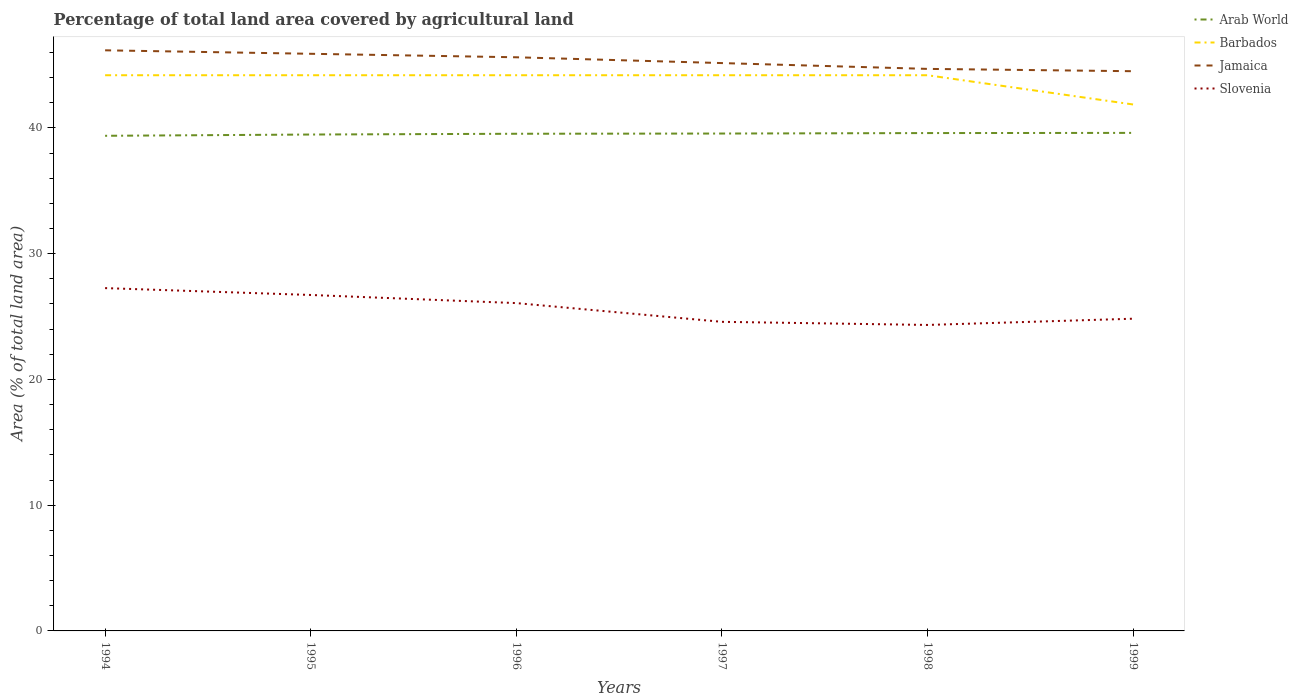Does the line corresponding to Arab World intersect with the line corresponding to Barbados?
Ensure brevity in your answer.  No. Across all years, what is the maximum percentage of agricultural land in Barbados?
Ensure brevity in your answer.  41.86. In which year was the percentage of agricultural land in Slovenia maximum?
Provide a succinct answer. 1998. What is the total percentage of agricultural land in Arab World in the graph?
Make the answer very short. -0.05. What is the difference between the highest and the second highest percentage of agricultural land in Slovenia?
Offer a very short reply. 2.93. What is the difference between the highest and the lowest percentage of agricultural land in Jamaica?
Your response must be concise. 3. How many lines are there?
Give a very brief answer. 4. How many years are there in the graph?
Give a very brief answer. 6. Does the graph contain any zero values?
Provide a short and direct response. No. Does the graph contain grids?
Make the answer very short. No. How many legend labels are there?
Make the answer very short. 4. What is the title of the graph?
Offer a terse response. Percentage of total land area covered by agricultural land. Does "Georgia" appear as one of the legend labels in the graph?
Ensure brevity in your answer.  No. What is the label or title of the X-axis?
Give a very brief answer. Years. What is the label or title of the Y-axis?
Offer a very short reply. Area (% of total land area). What is the Area (% of total land area) in Arab World in 1994?
Provide a short and direct response. 39.37. What is the Area (% of total land area) in Barbados in 1994?
Your response must be concise. 44.19. What is the Area (% of total land area) in Jamaica in 1994?
Give a very brief answer. 46.17. What is the Area (% of total land area) in Slovenia in 1994?
Give a very brief answer. 27.26. What is the Area (% of total land area) in Arab World in 1995?
Make the answer very short. 39.47. What is the Area (% of total land area) of Barbados in 1995?
Provide a succinct answer. 44.19. What is the Area (% of total land area) of Jamaica in 1995?
Provide a short and direct response. 45.89. What is the Area (% of total land area) of Slovenia in 1995?
Ensure brevity in your answer.  26.71. What is the Area (% of total land area) of Arab World in 1996?
Provide a short and direct response. 39.53. What is the Area (% of total land area) in Barbados in 1996?
Provide a short and direct response. 44.19. What is the Area (% of total land area) in Jamaica in 1996?
Your response must be concise. 45.61. What is the Area (% of total land area) in Slovenia in 1996?
Provide a succinct answer. 26.07. What is the Area (% of total land area) in Arab World in 1997?
Provide a succinct answer. 39.55. What is the Area (% of total land area) in Barbados in 1997?
Keep it short and to the point. 44.19. What is the Area (% of total land area) of Jamaica in 1997?
Provide a short and direct response. 45.15. What is the Area (% of total land area) in Slovenia in 1997?
Offer a very short reply. 24.58. What is the Area (% of total land area) of Arab World in 1998?
Provide a succinct answer. 39.59. What is the Area (% of total land area) in Barbados in 1998?
Make the answer very short. 44.19. What is the Area (% of total land area) of Jamaica in 1998?
Provide a short and direct response. 44.69. What is the Area (% of total land area) in Slovenia in 1998?
Keep it short and to the point. 24.33. What is the Area (% of total land area) of Arab World in 1999?
Make the answer very short. 39.6. What is the Area (% of total land area) of Barbados in 1999?
Offer a terse response. 41.86. What is the Area (% of total land area) in Jamaica in 1999?
Offer a terse response. 44.51. What is the Area (% of total land area) of Slovenia in 1999?
Offer a very short reply. 24.83. Across all years, what is the maximum Area (% of total land area) of Arab World?
Provide a succinct answer. 39.6. Across all years, what is the maximum Area (% of total land area) of Barbados?
Provide a short and direct response. 44.19. Across all years, what is the maximum Area (% of total land area) of Jamaica?
Provide a short and direct response. 46.17. Across all years, what is the maximum Area (% of total land area) of Slovenia?
Make the answer very short. 27.26. Across all years, what is the minimum Area (% of total land area) of Arab World?
Your answer should be compact. 39.37. Across all years, what is the minimum Area (% of total land area) in Barbados?
Give a very brief answer. 41.86. Across all years, what is the minimum Area (% of total land area) in Jamaica?
Offer a very short reply. 44.51. Across all years, what is the minimum Area (% of total land area) in Slovenia?
Keep it short and to the point. 24.33. What is the total Area (% of total land area) in Arab World in the graph?
Give a very brief answer. 237.11. What is the total Area (% of total land area) of Barbados in the graph?
Give a very brief answer. 262.79. What is the total Area (% of total land area) in Jamaica in the graph?
Your answer should be compact. 272.02. What is the total Area (% of total land area) of Slovenia in the graph?
Keep it short and to the point. 153.77. What is the difference between the Area (% of total land area) in Arab World in 1994 and that in 1995?
Your answer should be very brief. -0.1. What is the difference between the Area (% of total land area) of Jamaica in 1994 and that in 1995?
Offer a terse response. 0.28. What is the difference between the Area (% of total land area) in Slovenia in 1994 and that in 1995?
Offer a terse response. 0.55. What is the difference between the Area (% of total land area) of Arab World in 1994 and that in 1996?
Provide a succinct answer. -0.16. What is the difference between the Area (% of total land area) of Barbados in 1994 and that in 1996?
Give a very brief answer. 0. What is the difference between the Area (% of total land area) in Jamaica in 1994 and that in 1996?
Keep it short and to the point. 0.55. What is the difference between the Area (% of total land area) of Slovenia in 1994 and that in 1996?
Give a very brief answer. 1.19. What is the difference between the Area (% of total land area) of Arab World in 1994 and that in 1997?
Ensure brevity in your answer.  -0.18. What is the difference between the Area (% of total land area) of Barbados in 1994 and that in 1997?
Offer a very short reply. 0. What is the difference between the Area (% of total land area) in Jamaica in 1994 and that in 1997?
Give a very brief answer. 1.02. What is the difference between the Area (% of total land area) in Slovenia in 1994 and that in 1997?
Provide a succinct answer. 2.68. What is the difference between the Area (% of total land area) of Arab World in 1994 and that in 1998?
Make the answer very short. -0.22. What is the difference between the Area (% of total land area) of Jamaica in 1994 and that in 1998?
Ensure brevity in your answer.  1.48. What is the difference between the Area (% of total land area) of Slovenia in 1994 and that in 1998?
Your answer should be very brief. 2.93. What is the difference between the Area (% of total land area) of Arab World in 1994 and that in 1999?
Make the answer very short. -0.23. What is the difference between the Area (% of total land area) of Barbados in 1994 and that in 1999?
Give a very brief answer. 2.33. What is the difference between the Area (% of total land area) in Jamaica in 1994 and that in 1999?
Keep it short and to the point. 1.66. What is the difference between the Area (% of total land area) of Slovenia in 1994 and that in 1999?
Give a very brief answer. 2.43. What is the difference between the Area (% of total land area) of Arab World in 1995 and that in 1996?
Keep it short and to the point. -0.06. What is the difference between the Area (% of total land area) of Jamaica in 1995 and that in 1996?
Your response must be concise. 0.28. What is the difference between the Area (% of total land area) in Slovenia in 1995 and that in 1996?
Make the answer very short. 0.65. What is the difference between the Area (% of total land area) in Arab World in 1995 and that in 1997?
Your response must be concise. -0.08. What is the difference between the Area (% of total land area) in Barbados in 1995 and that in 1997?
Offer a terse response. 0. What is the difference between the Area (% of total land area) of Jamaica in 1995 and that in 1997?
Your answer should be very brief. 0.74. What is the difference between the Area (% of total land area) in Slovenia in 1995 and that in 1997?
Your answer should be very brief. 2.14. What is the difference between the Area (% of total land area) of Arab World in 1995 and that in 1998?
Give a very brief answer. -0.12. What is the difference between the Area (% of total land area) of Jamaica in 1995 and that in 1998?
Your response must be concise. 1.2. What is the difference between the Area (% of total land area) of Slovenia in 1995 and that in 1998?
Your answer should be compact. 2.38. What is the difference between the Area (% of total land area) in Arab World in 1995 and that in 1999?
Your answer should be compact. -0.13. What is the difference between the Area (% of total land area) of Barbados in 1995 and that in 1999?
Keep it short and to the point. 2.33. What is the difference between the Area (% of total land area) of Jamaica in 1995 and that in 1999?
Provide a succinct answer. 1.39. What is the difference between the Area (% of total land area) of Slovenia in 1995 and that in 1999?
Offer a very short reply. 1.89. What is the difference between the Area (% of total land area) in Arab World in 1996 and that in 1997?
Provide a short and direct response. -0.02. What is the difference between the Area (% of total land area) of Barbados in 1996 and that in 1997?
Offer a very short reply. 0. What is the difference between the Area (% of total land area) of Jamaica in 1996 and that in 1997?
Keep it short and to the point. 0.46. What is the difference between the Area (% of total land area) in Slovenia in 1996 and that in 1997?
Your response must be concise. 1.49. What is the difference between the Area (% of total land area) of Arab World in 1996 and that in 1998?
Provide a succinct answer. -0.05. What is the difference between the Area (% of total land area) of Barbados in 1996 and that in 1998?
Your answer should be very brief. 0. What is the difference between the Area (% of total land area) of Jamaica in 1996 and that in 1998?
Provide a short and direct response. 0.92. What is the difference between the Area (% of total land area) in Slovenia in 1996 and that in 1998?
Make the answer very short. 1.74. What is the difference between the Area (% of total land area) of Arab World in 1996 and that in 1999?
Offer a terse response. -0.07. What is the difference between the Area (% of total land area) in Barbados in 1996 and that in 1999?
Your answer should be compact. 2.33. What is the difference between the Area (% of total land area) in Jamaica in 1996 and that in 1999?
Make the answer very short. 1.11. What is the difference between the Area (% of total land area) in Slovenia in 1996 and that in 1999?
Keep it short and to the point. 1.24. What is the difference between the Area (% of total land area) in Arab World in 1997 and that in 1998?
Give a very brief answer. -0.04. What is the difference between the Area (% of total land area) in Jamaica in 1997 and that in 1998?
Your answer should be compact. 0.46. What is the difference between the Area (% of total land area) of Slovenia in 1997 and that in 1998?
Your answer should be very brief. 0.25. What is the difference between the Area (% of total land area) in Arab World in 1997 and that in 1999?
Your answer should be compact. -0.05. What is the difference between the Area (% of total land area) of Barbados in 1997 and that in 1999?
Your answer should be compact. 2.33. What is the difference between the Area (% of total land area) in Jamaica in 1997 and that in 1999?
Offer a very short reply. 0.65. What is the difference between the Area (% of total land area) in Slovenia in 1997 and that in 1999?
Make the answer very short. -0.25. What is the difference between the Area (% of total land area) in Arab World in 1998 and that in 1999?
Ensure brevity in your answer.  -0.01. What is the difference between the Area (% of total land area) in Barbados in 1998 and that in 1999?
Ensure brevity in your answer.  2.33. What is the difference between the Area (% of total land area) in Jamaica in 1998 and that in 1999?
Provide a short and direct response. 0.18. What is the difference between the Area (% of total land area) of Slovenia in 1998 and that in 1999?
Keep it short and to the point. -0.5. What is the difference between the Area (% of total land area) of Arab World in 1994 and the Area (% of total land area) of Barbados in 1995?
Offer a terse response. -4.82. What is the difference between the Area (% of total land area) of Arab World in 1994 and the Area (% of total land area) of Jamaica in 1995?
Your answer should be very brief. -6.52. What is the difference between the Area (% of total land area) in Arab World in 1994 and the Area (% of total land area) in Slovenia in 1995?
Provide a succinct answer. 12.66. What is the difference between the Area (% of total land area) in Barbados in 1994 and the Area (% of total land area) in Jamaica in 1995?
Provide a short and direct response. -1.71. What is the difference between the Area (% of total land area) in Barbados in 1994 and the Area (% of total land area) in Slovenia in 1995?
Offer a terse response. 17.47. What is the difference between the Area (% of total land area) of Jamaica in 1994 and the Area (% of total land area) of Slovenia in 1995?
Your answer should be very brief. 19.45. What is the difference between the Area (% of total land area) of Arab World in 1994 and the Area (% of total land area) of Barbados in 1996?
Your answer should be very brief. -4.82. What is the difference between the Area (% of total land area) of Arab World in 1994 and the Area (% of total land area) of Jamaica in 1996?
Offer a terse response. -6.24. What is the difference between the Area (% of total land area) in Arab World in 1994 and the Area (% of total land area) in Slovenia in 1996?
Keep it short and to the point. 13.3. What is the difference between the Area (% of total land area) in Barbados in 1994 and the Area (% of total land area) in Jamaica in 1996?
Your answer should be compact. -1.43. What is the difference between the Area (% of total land area) of Barbados in 1994 and the Area (% of total land area) of Slovenia in 1996?
Make the answer very short. 18.12. What is the difference between the Area (% of total land area) in Jamaica in 1994 and the Area (% of total land area) in Slovenia in 1996?
Your response must be concise. 20.1. What is the difference between the Area (% of total land area) in Arab World in 1994 and the Area (% of total land area) in Barbados in 1997?
Provide a succinct answer. -4.82. What is the difference between the Area (% of total land area) in Arab World in 1994 and the Area (% of total land area) in Jamaica in 1997?
Offer a terse response. -5.78. What is the difference between the Area (% of total land area) in Arab World in 1994 and the Area (% of total land area) in Slovenia in 1997?
Provide a succinct answer. 14.79. What is the difference between the Area (% of total land area) of Barbados in 1994 and the Area (% of total land area) of Jamaica in 1997?
Keep it short and to the point. -0.97. What is the difference between the Area (% of total land area) of Barbados in 1994 and the Area (% of total land area) of Slovenia in 1997?
Offer a terse response. 19.61. What is the difference between the Area (% of total land area) of Jamaica in 1994 and the Area (% of total land area) of Slovenia in 1997?
Your answer should be compact. 21.59. What is the difference between the Area (% of total land area) of Arab World in 1994 and the Area (% of total land area) of Barbados in 1998?
Your response must be concise. -4.82. What is the difference between the Area (% of total land area) of Arab World in 1994 and the Area (% of total land area) of Jamaica in 1998?
Give a very brief answer. -5.32. What is the difference between the Area (% of total land area) of Arab World in 1994 and the Area (% of total land area) of Slovenia in 1998?
Provide a succinct answer. 15.04. What is the difference between the Area (% of total land area) of Barbados in 1994 and the Area (% of total land area) of Jamaica in 1998?
Your answer should be compact. -0.5. What is the difference between the Area (% of total land area) of Barbados in 1994 and the Area (% of total land area) of Slovenia in 1998?
Your response must be concise. 19.86. What is the difference between the Area (% of total land area) of Jamaica in 1994 and the Area (% of total land area) of Slovenia in 1998?
Keep it short and to the point. 21.84. What is the difference between the Area (% of total land area) of Arab World in 1994 and the Area (% of total land area) of Barbados in 1999?
Keep it short and to the point. -2.49. What is the difference between the Area (% of total land area) of Arab World in 1994 and the Area (% of total land area) of Jamaica in 1999?
Keep it short and to the point. -5.14. What is the difference between the Area (% of total land area) in Arab World in 1994 and the Area (% of total land area) in Slovenia in 1999?
Provide a succinct answer. 14.54. What is the difference between the Area (% of total land area) of Barbados in 1994 and the Area (% of total land area) of Jamaica in 1999?
Make the answer very short. -0.32. What is the difference between the Area (% of total land area) of Barbados in 1994 and the Area (% of total land area) of Slovenia in 1999?
Give a very brief answer. 19.36. What is the difference between the Area (% of total land area) of Jamaica in 1994 and the Area (% of total land area) of Slovenia in 1999?
Your answer should be compact. 21.34. What is the difference between the Area (% of total land area) of Arab World in 1995 and the Area (% of total land area) of Barbados in 1996?
Your answer should be compact. -4.71. What is the difference between the Area (% of total land area) in Arab World in 1995 and the Area (% of total land area) in Jamaica in 1996?
Keep it short and to the point. -6.14. What is the difference between the Area (% of total land area) of Arab World in 1995 and the Area (% of total land area) of Slovenia in 1996?
Offer a very short reply. 13.4. What is the difference between the Area (% of total land area) of Barbados in 1995 and the Area (% of total land area) of Jamaica in 1996?
Your answer should be compact. -1.43. What is the difference between the Area (% of total land area) of Barbados in 1995 and the Area (% of total land area) of Slovenia in 1996?
Provide a succinct answer. 18.12. What is the difference between the Area (% of total land area) of Jamaica in 1995 and the Area (% of total land area) of Slovenia in 1996?
Provide a short and direct response. 19.82. What is the difference between the Area (% of total land area) in Arab World in 1995 and the Area (% of total land area) in Barbados in 1997?
Offer a terse response. -4.71. What is the difference between the Area (% of total land area) in Arab World in 1995 and the Area (% of total land area) in Jamaica in 1997?
Give a very brief answer. -5.68. What is the difference between the Area (% of total land area) in Arab World in 1995 and the Area (% of total land area) in Slovenia in 1997?
Give a very brief answer. 14.89. What is the difference between the Area (% of total land area) of Barbados in 1995 and the Area (% of total land area) of Jamaica in 1997?
Give a very brief answer. -0.97. What is the difference between the Area (% of total land area) of Barbados in 1995 and the Area (% of total land area) of Slovenia in 1997?
Give a very brief answer. 19.61. What is the difference between the Area (% of total land area) of Jamaica in 1995 and the Area (% of total land area) of Slovenia in 1997?
Offer a very short reply. 21.31. What is the difference between the Area (% of total land area) in Arab World in 1995 and the Area (% of total land area) in Barbados in 1998?
Your answer should be very brief. -4.71. What is the difference between the Area (% of total land area) in Arab World in 1995 and the Area (% of total land area) in Jamaica in 1998?
Make the answer very short. -5.22. What is the difference between the Area (% of total land area) of Arab World in 1995 and the Area (% of total land area) of Slovenia in 1998?
Ensure brevity in your answer.  15.14. What is the difference between the Area (% of total land area) of Barbados in 1995 and the Area (% of total land area) of Jamaica in 1998?
Your answer should be compact. -0.5. What is the difference between the Area (% of total land area) of Barbados in 1995 and the Area (% of total land area) of Slovenia in 1998?
Ensure brevity in your answer.  19.86. What is the difference between the Area (% of total land area) of Jamaica in 1995 and the Area (% of total land area) of Slovenia in 1998?
Provide a succinct answer. 21.56. What is the difference between the Area (% of total land area) of Arab World in 1995 and the Area (% of total land area) of Barbados in 1999?
Provide a succinct answer. -2.39. What is the difference between the Area (% of total land area) of Arab World in 1995 and the Area (% of total land area) of Jamaica in 1999?
Ensure brevity in your answer.  -5.03. What is the difference between the Area (% of total land area) in Arab World in 1995 and the Area (% of total land area) in Slovenia in 1999?
Make the answer very short. 14.64. What is the difference between the Area (% of total land area) of Barbados in 1995 and the Area (% of total land area) of Jamaica in 1999?
Provide a succinct answer. -0.32. What is the difference between the Area (% of total land area) of Barbados in 1995 and the Area (% of total land area) of Slovenia in 1999?
Your answer should be compact. 19.36. What is the difference between the Area (% of total land area) in Jamaica in 1995 and the Area (% of total land area) in Slovenia in 1999?
Give a very brief answer. 21.06. What is the difference between the Area (% of total land area) in Arab World in 1996 and the Area (% of total land area) in Barbados in 1997?
Make the answer very short. -4.65. What is the difference between the Area (% of total land area) in Arab World in 1996 and the Area (% of total land area) in Jamaica in 1997?
Ensure brevity in your answer.  -5.62. What is the difference between the Area (% of total land area) in Arab World in 1996 and the Area (% of total land area) in Slovenia in 1997?
Offer a very short reply. 14.95. What is the difference between the Area (% of total land area) in Barbados in 1996 and the Area (% of total land area) in Jamaica in 1997?
Your response must be concise. -0.97. What is the difference between the Area (% of total land area) of Barbados in 1996 and the Area (% of total land area) of Slovenia in 1997?
Ensure brevity in your answer.  19.61. What is the difference between the Area (% of total land area) of Jamaica in 1996 and the Area (% of total land area) of Slovenia in 1997?
Offer a terse response. 21.04. What is the difference between the Area (% of total land area) of Arab World in 1996 and the Area (% of total land area) of Barbados in 1998?
Provide a succinct answer. -4.65. What is the difference between the Area (% of total land area) in Arab World in 1996 and the Area (% of total land area) in Jamaica in 1998?
Keep it short and to the point. -5.16. What is the difference between the Area (% of total land area) in Arab World in 1996 and the Area (% of total land area) in Slovenia in 1998?
Ensure brevity in your answer.  15.2. What is the difference between the Area (% of total land area) in Barbados in 1996 and the Area (% of total land area) in Jamaica in 1998?
Your answer should be compact. -0.5. What is the difference between the Area (% of total land area) in Barbados in 1996 and the Area (% of total land area) in Slovenia in 1998?
Provide a succinct answer. 19.86. What is the difference between the Area (% of total land area) in Jamaica in 1996 and the Area (% of total land area) in Slovenia in 1998?
Your answer should be compact. 21.28. What is the difference between the Area (% of total land area) in Arab World in 1996 and the Area (% of total land area) in Barbados in 1999?
Offer a very short reply. -2.33. What is the difference between the Area (% of total land area) of Arab World in 1996 and the Area (% of total land area) of Jamaica in 1999?
Offer a very short reply. -4.97. What is the difference between the Area (% of total land area) in Arab World in 1996 and the Area (% of total land area) in Slovenia in 1999?
Your response must be concise. 14.71. What is the difference between the Area (% of total land area) in Barbados in 1996 and the Area (% of total land area) in Jamaica in 1999?
Make the answer very short. -0.32. What is the difference between the Area (% of total land area) of Barbados in 1996 and the Area (% of total land area) of Slovenia in 1999?
Keep it short and to the point. 19.36. What is the difference between the Area (% of total land area) of Jamaica in 1996 and the Area (% of total land area) of Slovenia in 1999?
Provide a succinct answer. 20.79. What is the difference between the Area (% of total land area) of Arab World in 1997 and the Area (% of total land area) of Barbados in 1998?
Ensure brevity in your answer.  -4.64. What is the difference between the Area (% of total land area) in Arab World in 1997 and the Area (% of total land area) in Jamaica in 1998?
Make the answer very short. -5.14. What is the difference between the Area (% of total land area) in Arab World in 1997 and the Area (% of total land area) in Slovenia in 1998?
Give a very brief answer. 15.22. What is the difference between the Area (% of total land area) of Barbados in 1997 and the Area (% of total land area) of Jamaica in 1998?
Make the answer very short. -0.5. What is the difference between the Area (% of total land area) of Barbados in 1997 and the Area (% of total land area) of Slovenia in 1998?
Make the answer very short. 19.86. What is the difference between the Area (% of total land area) of Jamaica in 1997 and the Area (% of total land area) of Slovenia in 1998?
Make the answer very short. 20.82. What is the difference between the Area (% of total land area) of Arab World in 1997 and the Area (% of total land area) of Barbados in 1999?
Your answer should be very brief. -2.31. What is the difference between the Area (% of total land area) of Arab World in 1997 and the Area (% of total land area) of Jamaica in 1999?
Offer a terse response. -4.96. What is the difference between the Area (% of total land area) of Arab World in 1997 and the Area (% of total land area) of Slovenia in 1999?
Your answer should be compact. 14.72. What is the difference between the Area (% of total land area) in Barbados in 1997 and the Area (% of total land area) in Jamaica in 1999?
Your answer should be very brief. -0.32. What is the difference between the Area (% of total land area) in Barbados in 1997 and the Area (% of total land area) in Slovenia in 1999?
Your answer should be very brief. 19.36. What is the difference between the Area (% of total land area) of Jamaica in 1997 and the Area (% of total land area) of Slovenia in 1999?
Make the answer very short. 20.33. What is the difference between the Area (% of total land area) of Arab World in 1998 and the Area (% of total land area) of Barbados in 1999?
Offer a very short reply. -2.27. What is the difference between the Area (% of total land area) of Arab World in 1998 and the Area (% of total land area) of Jamaica in 1999?
Provide a short and direct response. -4.92. What is the difference between the Area (% of total land area) of Arab World in 1998 and the Area (% of total land area) of Slovenia in 1999?
Provide a short and direct response. 14.76. What is the difference between the Area (% of total land area) of Barbados in 1998 and the Area (% of total land area) of Jamaica in 1999?
Keep it short and to the point. -0.32. What is the difference between the Area (% of total land area) in Barbados in 1998 and the Area (% of total land area) in Slovenia in 1999?
Provide a short and direct response. 19.36. What is the difference between the Area (% of total land area) in Jamaica in 1998 and the Area (% of total land area) in Slovenia in 1999?
Give a very brief answer. 19.86. What is the average Area (% of total land area) of Arab World per year?
Offer a terse response. 39.52. What is the average Area (% of total land area) in Barbados per year?
Offer a very short reply. 43.8. What is the average Area (% of total land area) in Jamaica per year?
Give a very brief answer. 45.34. What is the average Area (% of total land area) in Slovenia per year?
Provide a succinct answer. 25.63. In the year 1994, what is the difference between the Area (% of total land area) of Arab World and Area (% of total land area) of Barbados?
Ensure brevity in your answer.  -4.82. In the year 1994, what is the difference between the Area (% of total land area) of Arab World and Area (% of total land area) of Jamaica?
Provide a succinct answer. -6.8. In the year 1994, what is the difference between the Area (% of total land area) of Arab World and Area (% of total land area) of Slovenia?
Provide a succinct answer. 12.11. In the year 1994, what is the difference between the Area (% of total land area) of Barbados and Area (% of total land area) of Jamaica?
Keep it short and to the point. -1.98. In the year 1994, what is the difference between the Area (% of total land area) in Barbados and Area (% of total land area) in Slovenia?
Your answer should be compact. 16.93. In the year 1994, what is the difference between the Area (% of total land area) of Jamaica and Area (% of total land area) of Slovenia?
Offer a terse response. 18.91. In the year 1995, what is the difference between the Area (% of total land area) of Arab World and Area (% of total land area) of Barbados?
Keep it short and to the point. -4.71. In the year 1995, what is the difference between the Area (% of total land area) in Arab World and Area (% of total land area) in Jamaica?
Keep it short and to the point. -6.42. In the year 1995, what is the difference between the Area (% of total land area) in Arab World and Area (% of total land area) in Slovenia?
Make the answer very short. 12.76. In the year 1995, what is the difference between the Area (% of total land area) in Barbados and Area (% of total land area) in Jamaica?
Your answer should be compact. -1.71. In the year 1995, what is the difference between the Area (% of total land area) of Barbados and Area (% of total land area) of Slovenia?
Keep it short and to the point. 17.47. In the year 1995, what is the difference between the Area (% of total land area) of Jamaica and Area (% of total land area) of Slovenia?
Keep it short and to the point. 19.18. In the year 1996, what is the difference between the Area (% of total land area) in Arab World and Area (% of total land area) in Barbados?
Provide a succinct answer. -4.65. In the year 1996, what is the difference between the Area (% of total land area) in Arab World and Area (% of total land area) in Jamaica?
Your response must be concise. -6.08. In the year 1996, what is the difference between the Area (% of total land area) of Arab World and Area (% of total land area) of Slovenia?
Give a very brief answer. 13.46. In the year 1996, what is the difference between the Area (% of total land area) in Barbados and Area (% of total land area) in Jamaica?
Offer a very short reply. -1.43. In the year 1996, what is the difference between the Area (% of total land area) of Barbados and Area (% of total land area) of Slovenia?
Keep it short and to the point. 18.12. In the year 1996, what is the difference between the Area (% of total land area) of Jamaica and Area (% of total land area) of Slovenia?
Give a very brief answer. 19.55. In the year 1997, what is the difference between the Area (% of total land area) in Arab World and Area (% of total land area) in Barbados?
Give a very brief answer. -4.64. In the year 1997, what is the difference between the Area (% of total land area) in Arab World and Area (% of total land area) in Jamaica?
Your answer should be very brief. -5.6. In the year 1997, what is the difference between the Area (% of total land area) in Arab World and Area (% of total land area) in Slovenia?
Keep it short and to the point. 14.97. In the year 1997, what is the difference between the Area (% of total land area) in Barbados and Area (% of total land area) in Jamaica?
Ensure brevity in your answer.  -0.97. In the year 1997, what is the difference between the Area (% of total land area) in Barbados and Area (% of total land area) in Slovenia?
Provide a short and direct response. 19.61. In the year 1997, what is the difference between the Area (% of total land area) in Jamaica and Area (% of total land area) in Slovenia?
Ensure brevity in your answer.  20.57. In the year 1998, what is the difference between the Area (% of total land area) in Arab World and Area (% of total land area) in Barbados?
Provide a short and direct response. -4.6. In the year 1998, what is the difference between the Area (% of total land area) in Arab World and Area (% of total land area) in Jamaica?
Ensure brevity in your answer.  -5.1. In the year 1998, what is the difference between the Area (% of total land area) in Arab World and Area (% of total land area) in Slovenia?
Make the answer very short. 15.26. In the year 1998, what is the difference between the Area (% of total land area) of Barbados and Area (% of total land area) of Jamaica?
Provide a short and direct response. -0.5. In the year 1998, what is the difference between the Area (% of total land area) in Barbados and Area (% of total land area) in Slovenia?
Offer a terse response. 19.86. In the year 1998, what is the difference between the Area (% of total land area) of Jamaica and Area (% of total land area) of Slovenia?
Keep it short and to the point. 20.36. In the year 1999, what is the difference between the Area (% of total land area) of Arab World and Area (% of total land area) of Barbados?
Make the answer very short. -2.26. In the year 1999, what is the difference between the Area (% of total land area) in Arab World and Area (% of total land area) in Jamaica?
Offer a very short reply. -4.9. In the year 1999, what is the difference between the Area (% of total land area) of Arab World and Area (% of total land area) of Slovenia?
Offer a terse response. 14.78. In the year 1999, what is the difference between the Area (% of total land area) in Barbados and Area (% of total land area) in Jamaica?
Offer a terse response. -2.65. In the year 1999, what is the difference between the Area (% of total land area) in Barbados and Area (% of total land area) in Slovenia?
Offer a terse response. 17.03. In the year 1999, what is the difference between the Area (% of total land area) of Jamaica and Area (% of total land area) of Slovenia?
Your answer should be very brief. 19.68. What is the ratio of the Area (% of total land area) in Slovenia in 1994 to that in 1995?
Provide a succinct answer. 1.02. What is the ratio of the Area (% of total land area) in Arab World in 1994 to that in 1996?
Give a very brief answer. 1. What is the ratio of the Area (% of total land area) in Barbados in 1994 to that in 1996?
Ensure brevity in your answer.  1. What is the ratio of the Area (% of total land area) in Jamaica in 1994 to that in 1996?
Provide a short and direct response. 1.01. What is the ratio of the Area (% of total land area) of Slovenia in 1994 to that in 1996?
Your response must be concise. 1.05. What is the ratio of the Area (% of total land area) of Barbados in 1994 to that in 1997?
Provide a succinct answer. 1. What is the ratio of the Area (% of total land area) of Jamaica in 1994 to that in 1997?
Offer a very short reply. 1.02. What is the ratio of the Area (% of total land area) in Slovenia in 1994 to that in 1997?
Your answer should be very brief. 1.11. What is the ratio of the Area (% of total land area) of Arab World in 1994 to that in 1998?
Provide a short and direct response. 0.99. What is the ratio of the Area (% of total land area) in Jamaica in 1994 to that in 1998?
Your answer should be compact. 1.03. What is the ratio of the Area (% of total land area) in Slovenia in 1994 to that in 1998?
Your response must be concise. 1.12. What is the ratio of the Area (% of total land area) of Barbados in 1994 to that in 1999?
Provide a succinct answer. 1.06. What is the ratio of the Area (% of total land area) in Jamaica in 1994 to that in 1999?
Ensure brevity in your answer.  1.04. What is the ratio of the Area (% of total land area) of Slovenia in 1994 to that in 1999?
Make the answer very short. 1.1. What is the ratio of the Area (% of total land area) of Arab World in 1995 to that in 1996?
Make the answer very short. 1. What is the ratio of the Area (% of total land area) in Jamaica in 1995 to that in 1996?
Your answer should be very brief. 1.01. What is the ratio of the Area (% of total land area) of Slovenia in 1995 to that in 1996?
Give a very brief answer. 1.02. What is the ratio of the Area (% of total land area) in Arab World in 1995 to that in 1997?
Offer a terse response. 1. What is the ratio of the Area (% of total land area) of Barbados in 1995 to that in 1997?
Your answer should be very brief. 1. What is the ratio of the Area (% of total land area) of Jamaica in 1995 to that in 1997?
Offer a terse response. 1.02. What is the ratio of the Area (% of total land area) of Slovenia in 1995 to that in 1997?
Provide a short and direct response. 1.09. What is the ratio of the Area (% of total land area) in Jamaica in 1995 to that in 1998?
Give a very brief answer. 1.03. What is the ratio of the Area (% of total land area) in Slovenia in 1995 to that in 1998?
Offer a terse response. 1.1. What is the ratio of the Area (% of total land area) in Arab World in 1995 to that in 1999?
Your response must be concise. 1. What is the ratio of the Area (% of total land area) of Barbados in 1995 to that in 1999?
Offer a terse response. 1.06. What is the ratio of the Area (% of total land area) in Jamaica in 1995 to that in 1999?
Your response must be concise. 1.03. What is the ratio of the Area (% of total land area) in Slovenia in 1995 to that in 1999?
Your answer should be very brief. 1.08. What is the ratio of the Area (% of total land area) of Arab World in 1996 to that in 1997?
Ensure brevity in your answer.  1. What is the ratio of the Area (% of total land area) in Barbados in 1996 to that in 1997?
Your response must be concise. 1. What is the ratio of the Area (% of total land area) of Jamaica in 1996 to that in 1997?
Your response must be concise. 1.01. What is the ratio of the Area (% of total land area) of Slovenia in 1996 to that in 1997?
Offer a very short reply. 1.06. What is the ratio of the Area (% of total land area) in Barbados in 1996 to that in 1998?
Your response must be concise. 1. What is the ratio of the Area (% of total land area) of Jamaica in 1996 to that in 1998?
Provide a short and direct response. 1.02. What is the ratio of the Area (% of total land area) in Slovenia in 1996 to that in 1998?
Offer a very short reply. 1.07. What is the ratio of the Area (% of total land area) of Barbados in 1996 to that in 1999?
Offer a terse response. 1.06. What is the ratio of the Area (% of total land area) of Jamaica in 1996 to that in 1999?
Keep it short and to the point. 1.02. What is the ratio of the Area (% of total land area) in Slovenia in 1996 to that in 1999?
Your answer should be compact. 1.05. What is the ratio of the Area (% of total land area) in Arab World in 1997 to that in 1998?
Your answer should be very brief. 1. What is the ratio of the Area (% of total land area) in Barbados in 1997 to that in 1998?
Offer a terse response. 1. What is the ratio of the Area (% of total land area) of Jamaica in 1997 to that in 1998?
Ensure brevity in your answer.  1.01. What is the ratio of the Area (% of total land area) of Slovenia in 1997 to that in 1998?
Offer a very short reply. 1.01. What is the ratio of the Area (% of total land area) in Barbados in 1997 to that in 1999?
Ensure brevity in your answer.  1.06. What is the ratio of the Area (% of total land area) of Jamaica in 1997 to that in 1999?
Your answer should be very brief. 1.01. What is the ratio of the Area (% of total land area) of Arab World in 1998 to that in 1999?
Make the answer very short. 1. What is the ratio of the Area (% of total land area) in Barbados in 1998 to that in 1999?
Make the answer very short. 1.06. What is the difference between the highest and the second highest Area (% of total land area) in Arab World?
Your response must be concise. 0.01. What is the difference between the highest and the second highest Area (% of total land area) of Barbados?
Provide a succinct answer. 0. What is the difference between the highest and the second highest Area (% of total land area) of Jamaica?
Offer a terse response. 0.28. What is the difference between the highest and the second highest Area (% of total land area) of Slovenia?
Your answer should be very brief. 0.55. What is the difference between the highest and the lowest Area (% of total land area) of Arab World?
Your answer should be very brief. 0.23. What is the difference between the highest and the lowest Area (% of total land area) in Barbados?
Your response must be concise. 2.33. What is the difference between the highest and the lowest Area (% of total land area) in Jamaica?
Provide a short and direct response. 1.66. What is the difference between the highest and the lowest Area (% of total land area) of Slovenia?
Your answer should be compact. 2.93. 